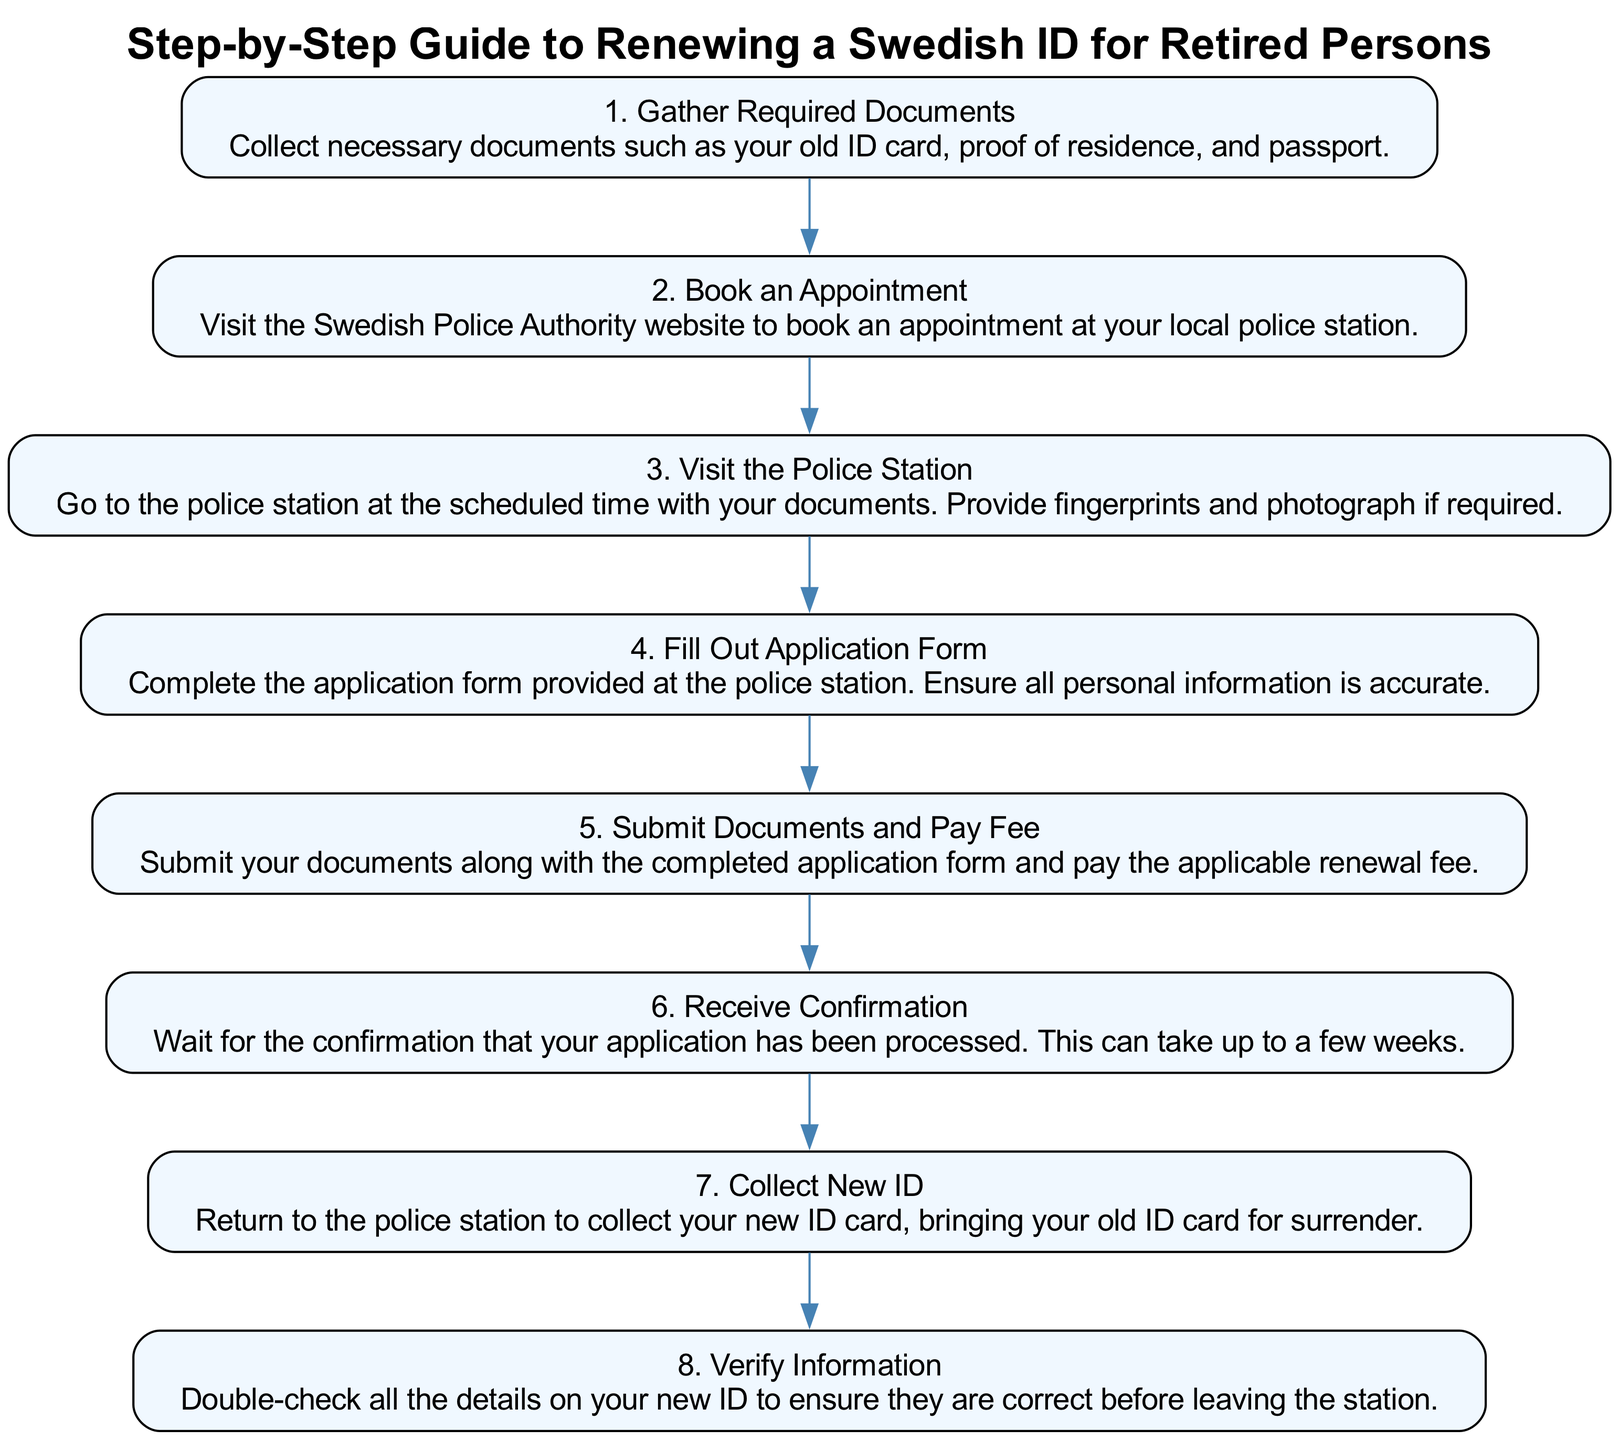What is the first step in the process? The first step is labeled as "1. Gather Required Documents," which outlines the initial action needed to start the renewal process.
Answer: Gather Required Documents How many steps are there in total? The diagram includes a total of eight steps, numbered from 1 to 8.
Answer: 8 What do you need to submit along with the application form? The instruction states you need to submit your documents along with the completed application form when paying the renewal fee.
Answer: Documents and application form What happens after you collect the new ID? After collecting the new ID, the next action is to "Verify Information," ensuring that all details on the new ID are correct.
Answer: Verify Information What step involves visiting the police station? "3. Visit the Police Station" is the step that requires going to the police station at the scheduled time with the necessary documents.
Answer: Visit the Police Station Which step comes immediately after 'Fill Out Application Form'? The next step immediately after 'Fill Out Application Form' is 'Submit Documents and Pay Fee,' which indicates the progression in the application process.
Answer: Submit Documents and Pay Fee What is required at step 3? At step 3, you are required to go to the police station with your documents and provide fingerprints and a photograph if necessary.
Answer: Provide fingerprints and photograph How long does it take to receive confirmation of application processing? The confirmation that the application has been processed may take up to a few weeks, according to the details in that step.
Answer: A few weeks 